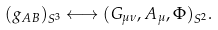Convert formula to latex. <formula><loc_0><loc_0><loc_500><loc_500>( g _ { A B } ) _ { S ^ { 3 } } \longleftrightarrow ( G _ { \mu \nu } , A _ { \mu } , \Phi ) _ { S ^ { 2 } } .</formula> 